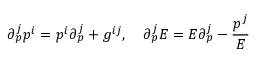<formula> <loc_0><loc_0><loc_500><loc_500>\partial _ { p } ^ { j } p ^ { i } = p ^ { i } \partial _ { p } ^ { j } + g ^ { i j } , \quad \partial _ { p } ^ { j } E = E \partial _ { p } ^ { j } - \frac { p ^ { j } } { E }</formula> 